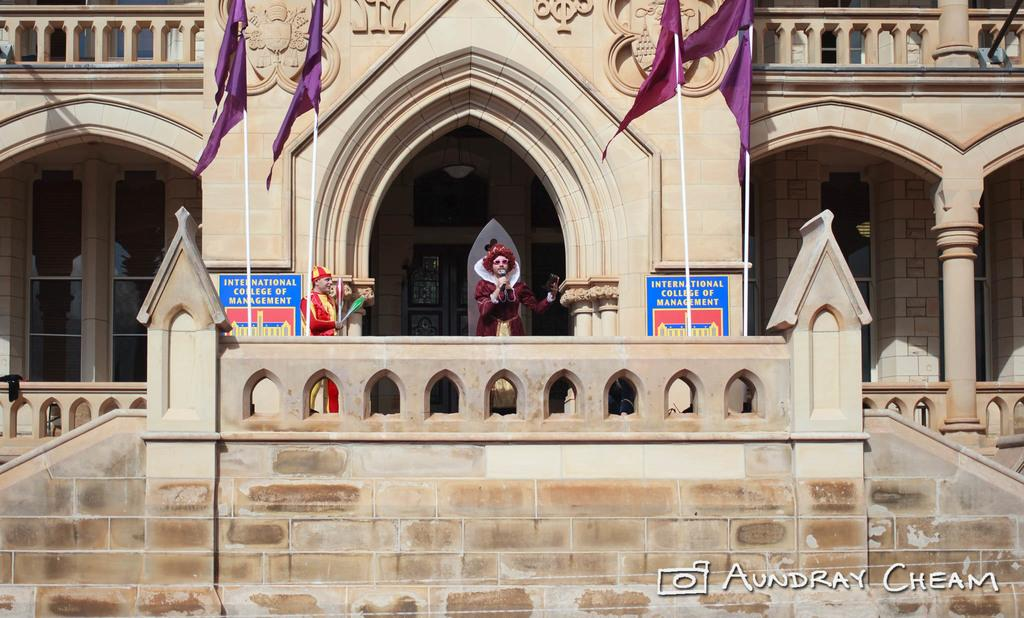What is the person holding in the image? The person is holding a mic in the image. Can you describe another person in the image? There is a man standing in the image. What decorative items can be seen in the image? There are posters and flags in the image. What architectural features are present in the image? There are poles, pillars, and a building with windows in the image. What type of gun is the person holding in the image? There is no gun present in the image; the person is holding a mic. Can you tell me how many brothers are in the image? There is no mention of a brother or any family members in the image. 